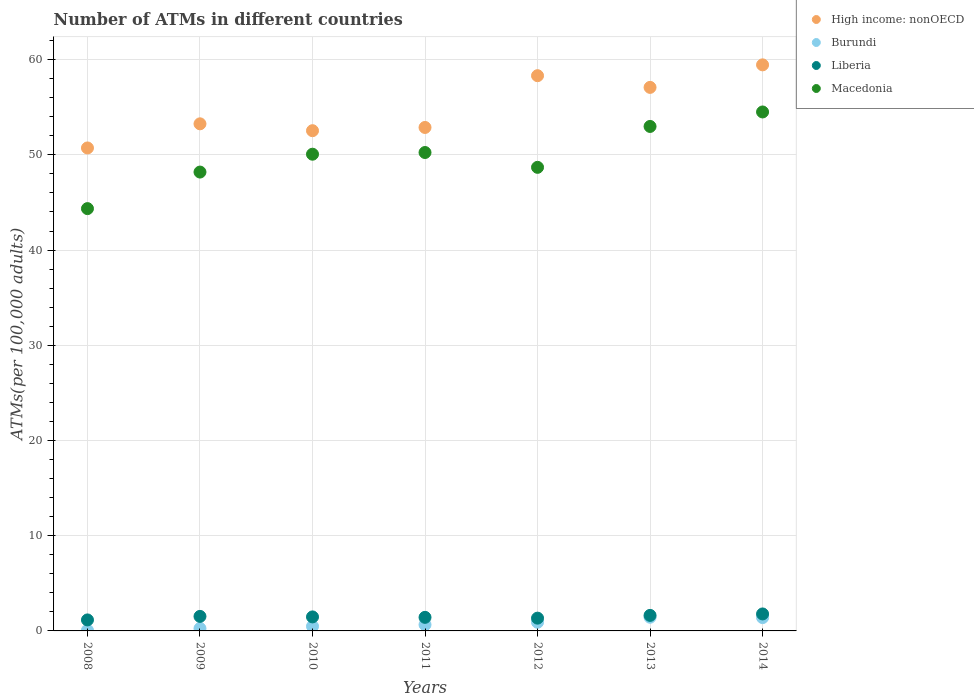How many different coloured dotlines are there?
Ensure brevity in your answer.  4. Is the number of dotlines equal to the number of legend labels?
Make the answer very short. Yes. What is the number of ATMs in Burundi in 2014?
Your response must be concise. 1.4. Across all years, what is the maximum number of ATMs in Liberia?
Make the answer very short. 1.78. Across all years, what is the minimum number of ATMs in Liberia?
Your answer should be compact. 1.16. In which year was the number of ATMs in High income: nonOECD maximum?
Give a very brief answer. 2014. What is the total number of ATMs in Burundi in the graph?
Make the answer very short. 5.21. What is the difference between the number of ATMs in Macedonia in 2008 and that in 2009?
Ensure brevity in your answer.  -3.84. What is the difference between the number of ATMs in Burundi in 2012 and the number of ATMs in High income: nonOECD in 2008?
Give a very brief answer. -49.81. What is the average number of ATMs in High income: nonOECD per year?
Offer a terse response. 54.89. In the year 2010, what is the difference between the number of ATMs in Liberia and number of ATMs in Burundi?
Your answer should be compact. 0.99. In how many years, is the number of ATMs in Macedonia greater than 14?
Your answer should be compact. 7. What is the ratio of the number of ATMs in High income: nonOECD in 2010 to that in 2012?
Give a very brief answer. 0.9. Is the number of ATMs in Liberia in 2008 less than that in 2014?
Offer a terse response. Yes. What is the difference between the highest and the second highest number of ATMs in Macedonia?
Make the answer very short. 1.52. What is the difference between the highest and the lowest number of ATMs in Liberia?
Keep it short and to the point. 0.63. In how many years, is the number of ATMs in Burundi greater than the average number of ATMs in Burundi taken over all years?
Ensure brevity in your answer.  3. Is the sum of the number of ATMs in Liberia in 2012 and 2013 greater than the maximum number of ATMs in High income: nonOECD across all years?
Provide a succinct answer. No. Does the number of ATMs in Liberia monotonically increase over the years?
Ensure brevity in your answer.  No. Is the number of ATMs in Liberia strictly greater than the number of ATMs in Macedonia over the years?
Give a very brief answer. No. Is the number of ATMs in Macedonia strictly less than the number of ATMs in Liberia over the years?
Make the answer very short. No. How many years are there in the graph?
Provide a succinct answer. 7. What is the difference between two consecutive major ticks on the Y-axis?
Your response must be concise. 10. Does the graph contain grids?
Your answer should be very brief. Yes. How many legend labels are there?
Offer a terse response. 4. How are the legend labels stacked?
Your answer should be compact. Vertical. What is the title of the graph?
Keep it short and to the point. Number of ATMs in different countries. What is the label or title of the Y-axis?
Keep it short and to the point. ATMs(per 100,0 adults). What is the ATMs(per 100,000 adults) in High income: nonOECD in 2008?
Your response must be concise. 50.72. What is the ATMs(per 100,000 adults) of Burundi in 2008?
Offer a terse response. 0.06. What is the ATMs(per 100,000 adults) of Liberia in 2008?
Your response must be concise. 1.16. What is the ATMs(per 100,000 adults) in Macedonia in 2008?
Offer a very short reply. 44.35. What is the ATMs(per 100,000 adults) of High income: nonOECD in 2009?
Make the answer very short. 53.26. What is the ATMs(per 100,000 adults) in Burundi in 2009?
Make the answer very short. 0.26. What is the ATMs(per 100,000 adults) in Liberia in 2009?
Provide a short and direct response. 1.53. What is the ATMs(per 100,000 adults) in Macedonia in 2009?
Keep it short and to the point. 48.19. What is the ATMs(per 100,000 adults) in High income: nonOECD in 2010?
Offer a very short reply. 52.53. What is the ATMs(per 100,000 adults) in Burundi in 2010?
Provide a succinct answer. 0.48. What is the ATMs(per 100,000 adults) in Liberia in 2010?
Make the answer very short. 1.47. What is the ATMs(per 100,000 adults) of Macedonia in 2010?
Ensure brevity in your answer.  50.07. What is the ATMs(per 100,000 adults) of High income: nonOECD in 2011?
Your response must be concise. 52.87. What is the ATMs(per 100,000 adults) in Burundi in 2011?
Make the answer very short. 0.66. What is the ATMs(per 100,000 adults) of Liberia in 2011?
Provide a succinct answer. 1.42. What is the ATMs(per 100,000 adults) of Macedonia in 2011?
Ensure brevity in your answer.  50.24. What is the ATMs(per 100,000 adults) in High income: nonOECD in 2012?
Offer a very short reply. 58.31. What is the ATMs(per 100,000 adults) in Burundi in 2012?
Your answer should be very brief. 0.91. What is the ATMs(per 100,000 adults) of Liberia in 2012?
Your response must be concise. 1.34. What is the ATMs(per 100,000 adults) in Macedonia in 2012?
Your answer should be very brief. 48.69. What is the ATMs(per 100,000 adults) in High income: nonOECD in 2013?
Provide a succinct answer. 57.08. What is the ATMs(per 100,000 adults) of Burundi in 2013?
Offer a very short reply. 1.44. What is the ATMs(per 100,000 adults) of Liberia in 2013?
Provide a short and direct response. 1.63. What is the ATMs(per 100,000 adults) in Macedonia in 2013?
Your response must be concise. 52.98. What is the ATMs(per 100,000 adults) of High income: nonOECD in 2014?
Keep it short and to the point. 59.45. What is the ATMs(per 100,000 adults) of Burundi in 2014?
Offer a very short reply. 1.4. What is the ATMs(per 100,000 adults) in Liberia in 2014?
Offer a very short reply. 1.78. What is the ATMs(per 100,000 adults) in Macedonia in 2014?
Give a very brief answer. 54.5. Across all years, what is the maximum ATMs(per 100,000 adults) in High income: nonOECD?
Ensure brevity in your answer.  59.45. Across all years, what is the maximum ATMs(per 100,000 adults) of Burundi?
Offer a terse response. 1.44. Across all years, what is the maximum ATMs(per 100,000 adults) in Liberia?
Provide a short and direct response. 1.78. Across all years, what is the maximum ATMs(per 100,000 adults) of Macedonia?
Offer a very short reply. 54.5. Across all years, what is the minimum ATMs(per 100,000 adults) in High income: nonOECD?
Your answer should be very brief. 50.72. Across all years, what is the minimum ATMs(per 100,000 adults) of Burundi?
Make the answer very short. 0.06. Across all years, what is the minimum ATMs(per 100,000 adults) in Liberia?
Ensure brevity in your answer.  1.16. Across all years, what is the minimum ATMs(per 100,000 adults) in Macedonia?
Your response must be concise. 44.35. What is the total ATMs(per 100,000 adults) of High income: nonOECD in the graph?
Ensure brevity in your answer.  384.23. What is the total ATMs(per 100,000 adults) of Burundi in the graph?
Make the answer very short. 5.21. What is the total ATMs(per 100,000 adults) in Liberia in the graph?
Offer a terse response. 10.33. What is the total ATMs(per 100,000 adults) of Macedonia in the graph?
Offer a very short reply. 349.02. What is the difference between the ATMs(per 100,000 adults) of High income: nonOECD in 2008 and that in 2009?
Make the answer very short. -2.53. What is the difference between the ATMs(per 100,000 adults) in Burundi in 2008 and that in 2009?
Offer a terse response. -0.2. What is the difference between the ATMs(per 100,000 adults) of Liberia in 2008 and that in 2009?
Your answer should be very brief. -0.37. What is the difference between the ATMs(per 100,000 adults) of Macedonia in 2008 and that in 2009?
Provide a short and direct response. -3.84. What is the difference between the ATMs(per 100,000 adults) of High income: nonOECD in 2008 and that in 2010?
Offer a terse response. -1.81. What is the difference between the ATMs(per 100,000 adults) of Burundi in 2008 and that in 2010?
Keep it short and to the point. -0.42. What is the difference between the ATMs(per 100,000 adults) in Liberia in 2008 and that in 2010?
Provide a succinct answer. -0.32. What is the difference between the ATMs(per 100,000 adults) in Macedonia in 2008 and that in 2010?
Your answer should be very brief. -5.71. What is the difference between the ATMs(per 100,000 adults) in High income: nonOECD in 2008 and that in 2011?
Your response must be concise. -2.15. What is the difference between the ATMs(per 100,000 adults) of Burundi in 2008 and that in 2011?
Offer a very short reply. -0.59. What is the difference between the ATMs(per 100,000 adults) of Liberia in 2008 and that in 2011?
Keep it short and to the point. -0.27. What is the difference between the ATMs(per 100,000 adults) in Macedonia in 2008 and that in 2011?
Make the answer very short. -5.89. What is the difference between the ATMs(per 100,000 adults) of High income: nonOECD in 2008 and that in 2012?
Offer a terse response. -7.59. What is the difference between the ATMs(per 100,000 adults) of Burundi in 2008 and that in 2012?
Ensure brevity in your answer.  -0.85. What is the difference between the ATMs(per 100,000 adults) in Liberia in 2008 and that in 2012?
Your answer should be compact. -0.19. What is the difference between the ATMs(per 100,000 adults) of Macedonia in 2008 and that in 2012?
Provide a succinct answer. -4.34. What is the difference between the ATMs(per 100,000 adults) in High income: nonOECD in 2008 and that in 2013?
Provide a short and direct response. -6.36. What is the difference between the ATMs(per 100,000 adults) of Burundi in 2008 and that in 2013?
Your answer should be compact. -1.38. What is the difference between the ATMs(per 100,000 adults) in Liberia in 2008 and that in 2013?
Provide a short and direct response. -0.48. What is the difference between the ATMs(per 100,000 adults) in Macedonia in 2008 and that in 2013?
Offer a very short reply. -8.63. What is the difference between the ATMs(per 100,000 adults) in High income: nonOECD in 2008 and that in 2014?
Provide a succinct answer. -8.73. What is the difference between the ATMs(per 100,000 adults) in Burundi in 2008 and that in 2014?
Your answer should be very brief. -1.34. What is the difference between the ATMs(per 100,000 adults) of Liberia in 2008 and that in 2014?
Your answer should be very brief. -0.63. What is the difference between the ATMs(per 100,000 adults) in Macedonia in 2008 and that in 2014?
Your answer should be very brief. -10.15. What is the difference between the ATMs(per 100,000 adults) of High income: nonOECD in 2009 and that in 2010?
Provide a short and direct response. 0.72. What is the difference between the ATMs(per 100,000 adults) of Burundi in 2009 and that in 2010?
Your answer should be very brief. -0.22. What is the difference between the ATMs(per 100,000 adults) in Liberia in 2009 and that in 2010?
Give a very brief answer. 0.05. What is the difference between the ATMs(per 100,000 adults) in Macedonia in 2009 and that in 2010?
Your answer should be very brief. -1.88. What is the difference between the ATMs(per 100,000 adults) in High income: nonOECD in 2009 and that in 2011?
Offer a terse response. 0.38. What is the difference between the ATMs(per 100,000 adults) of Burundi in 2009 and that in 2011?
Your response must be concise. -0.4. What is the difference between the ATMs(per 100,000 adults) in Liberia in 2009 and that in 2011?
Your response must be concise. 0.1. What is the difference between the ATMs(per 100,000 adults) of Macedonia in 2009 and that in 2011?
Your answer should be very brief. -2.05. What is the difference between the ATMs(per 100,000 adults) of High income: nonOECD in 2009 and that in 2012?
Your response must be concise. -5.05. What is the difference between the ATMs(per 100,000 adults) in Burundi in 2009 and that in 2012?
Give a very brief answer. -0.65. What is the difference between the ATMs(per 100,000 adults) in Liberia in 2009 and that in 2012?
Keep it short and to the point. 0.19. What is the difference between the ATMs(per 100,000 adults) in Macedonia in 2009 and that in 2012?
Provide a succinct answer. -0.5. What is the difference between the ATMs(per 100,000 adults) in High income: nonOECD in 2009 and that in 2013?
Your answer should be very brief. -3.83. What is the difference between the ATMs(per 100,000 adults) of Burundi in 2009 and that in 2013?
Offer a very short reply. -1.18. What is the difference between the ATMs(per 100,000 adults) of Liberia in 2009 and that in 2013?
Your response must be concise. -0.1. What is the difference between the ATMs(per 100,000 adults) of Macedonia in 2009 and that in 2013?
Give a very brief answer. -4.79. What is the difference between the ATMs(per 100,000 adults) in High income: nonOECD in 2009 and that in 2014?
Offer a terse response. -6.19. What is the difference between the ATMs(per 100,000 adults) in Burundi in 2009 and that in 2014?
Provide a short and direct response. -1.14. What is the difference between the ATMs(per 100,000 adults) in Liberia in 2009 and that in 2014?
Give a very brief answer. -0.26. What is the difference between the ATMs(per 100,000 adults) in Macedonia in 2009 and that in 2014?
Make the answer very short. -6.31. What is the difference between the ATMs(per 100,000 adults) of High income: nonOECD in 2010 and that in 2011?
Make the answer very short. -0.34. What is the difference between the ATMs(per 100,000 adults) in Burundi in 2010 and that in 2011?
Make the answer very short. -0.17. What is the difference between the ATMs(per 100,000 adults) in Liberia in 2010 and that in 2011?
Your response must be concise. 0.05. What is the difference between the ATMs(per 100,000 adults) of Macedonia in 2010 and that in 2011?
Your answer should be very brief. -0.18. What is the difference between the ATMs(per 100,000 adults) in High income: nonOECD in 2010 and that in 2012?
Keep it short and to the point. -5.78. What is the difference between the ATMs(per 100,000 adults) of Burundi in 2010 and that in 2012?
Keep it short and to the point. -0.43. What is the difference between the ATMs(per 100,000 adults) of Liberia in 2010 and that in 2012?
Your answer should be compact. 0.13. What is the difference between the ATMs(per 100,000 adults) in Macedonia in 2010 and that in 2012?
Provide a succinct answer. 1.38. What is the difference between the ATMs(per 100,000 adults) in High income: nonOECD in 2010 and that in 2013?
Ensure brevity in your answer.  -4.55. What is the difference between the ATMs(per 100,000 adults) in Burundi in 2010 and that in 2013?
Your response must be concise. -0.95. What is the difference between the ATMs(per 100,000 adults) in Liberia in 2010 and that in 2013?
Make the answer very short. -0.16. What is the difference between the ATMs(per 100,000 adults) of Macedonia in 2010 and that in 2013?
Your answer should be very brief. -2.92. What is the difference between the ATMs(per 100,000 adults) of High income: nonOECD in 2010 and that in 2014?
Keep it short and to the point. -6.92. What is the difference between the ATMs(per 100,000 adults) of Burundi in 2010 and that in 2014?
Keep it short and to the point. -0.92. What is the difference between the ATMs(per 100,000 adults) in Liberia in 2010 and that in 2014?
Provide a short and direct response. -0.31. What is the difference between the ATMs(per 100,000 adults) in Macedonia in 2010 and that in 2014?
Give a very brief answer. -4.44. What is the difference between the ATMs(per 100,000 adults) in High income: nonOECD in 2011 and that in 2012?
Give a very brief answer. -5.44. What is the difference between the ATMs(per 100,000 adults) of Burundi in 2011 and that in 2012?
Offer a very short reply. -0.25. What is the difference between the ATMs(per 100,000 adults) in Liberia in 2011 and that in 2012?
Offer a very short reply. 0.08. What is the difference between the ATMs(per 100,000 adults) in Macedonia in 2011 and that in 2012?
Provide a succinct answer. 1.56. What is the difference between the ATMs(per 100,000 adults) of High income: nonOECD in 2011 and that in 2013?
Make the answer very short. -4.21. What is the difference between the ATMs(per 100,000 adults) of Burundi in 2011 and that in 2013?
Provide a succinct answer. -0.78. What is the difference between the ATMs(per 100,000 adults) in Liberia in 2011 and that in 2013?
Provide a succinct answer. -0.21. What is the difference between the ATMs(per 100,000 adults) of Macedonia in 2011 and that in 2013?
Your response must be concise. -2.74. What is the difference between the ATMs(per 100,000 adults) of High income: nonOECD in 2011 and that in 2014?
Your answer should be compact. -6.58. What is the difference between the ATMs(per 100,000 adults) in Burundi in 2011 and that in 2014?
Offer a very short reply. -0.74. What is the difference between the ATMs(per 100,000 adults) of Liberia in 2011 and that in 2014?
Your response must be concise. -0.36. What is the difference between the ATMs(per 100,000 adults) in Macedonia in 2011 and that in 2014?
Ensure brevity in your answer.  -4.26. What is the difference between the ATMs(per 100,000 adults) in High income: nonOECD in 2012 and that in 2013?
Your answer should be compact. 1.23. What is the difference between the ATMs(per 100,000 adults) in Burundi in 2012 and that in 2013?
Offer a terse response. -0.53. What is the difference between the ATMs(per 100,000 adults) in Liberia in 2012 and that in 2013?
Provide a short and direct response. -0.29. What is the difference between the ATMs(per 100,000 adults) of Macedonia in 2012 and that in 2013?
Provide a short and direct response. -4.29. What is the difference between the ATMs(per 100,000 adults) in High income: nonOECD in 2012 and that in 2014?
Provide a short and direct response. -1.14. What is the difference between the ATMs(per 100,000 adults) of Burundi in 2012 and that in 2014?
Your answer should be compact. -0.49. What is the difference between the ATMs(per 100,000 adults) in Liberia in 2012 and that in 2014?
Keep it short and to the point. -0.44. What is the difference between the ATMs(per 100,000 adults) of Macedonia in 2012 and that in 2014?
Give a very brief answer. -5.81. What is the difference between the ATMs(per 100,000 adults) in High income: nonOECD in 2013 and that in 2014?
Ensure brevity in your answer.  -2.37. What is the difference between the ATMs(per 100,000 adults) of Burundi in 2013 and that in 2014?
Provide a short and direct response. 0.04. What is the difference between the ATMs(per 100,000 adults) of Liberia in 2013 and that in 2014?
Ensure brevity in your answer.  -0.15. What is the difference between the ATMs(per 100,000 adults) of Macedonia in 2013 and that in 2014?
Make the answer very short. -1.52. What is the difference between the ATMs(per 100,000 adults) in High income: nonOECD in 2008 and the ATMs(per 100,000 adults) in Burundi in 2009?
Your response must be concise. 50.46. What is the difference between the ATMs(per 100,000 adults) of High income: nonOECD in 2008 and the ATMs(per 100,000 adults) of Liberia in 2009?
Offer a very short reply. 49.2. What is the difference between the ATMs(per 100,000 adults) in High income: nonOECD in 2008 and the ATMs(per 100,000 adults) in Macedonia in 2009?
Give a very brief answer. 2.53. What is the difference between the ATMs(per 100,000 adults) in Burundi in 2008 and the ATMs(per 100,000 adults) in Liberia in 2009?
Offer a very short reply. -1.46. What is the difference between the ATMs(per 100,000 adults) in Burundi in 2008 and the ATMs(per 100,000 adults) in Macedonia in 2009?
Offer a very short reply. -48.13. What is the difference between the ATMs(per 100,000 adults) of Liberia in 2008 and the ATMs(per 100,000 adults) of Macedonia in 2009?
Offer a terse response. -47.03. What is the difference between the ATMs(per 100,000 adults) of High income: nonOECD in 2008 and the ATMs(per 100,000 adults) of Burundi in 2010?
Your answer should be compact. 50.24. What is the difference between the ATMs(per 100,000 adults) of High income: nonOECD in 2008 and the ATMs(per 100,000 adults) of Liberia in 2010?
Keep it short and to the point. 49.25. What is the difference between the ATMs(per 100,000 adults) in High income: nonOECD in 2008 and the ATMs(per 100,000 adults) in Macedonia in 2010?
Your response must be concise. 0.66. What is the difference between the ATMs(per 100,000 adults) in Burundi in 2008 and the ATMs(per 100,000 adults) in Liberia in 2010?
Offer a very short reply. -1.41. What is the difference between the ATMs(per 100,000 adults) in Burundi in 2008 and the ATMs(per 100,000 adults) in Macedonia in 2010?
Your answer should be very brief. -50. What is the difference between the ATMs(per 100,000 adults) of Liberia in 2008 and the ATMs(per 100,000 adults) of Macedonia in 2010?
Offer a terse response. -48.91. What is the difference between the ATMs(per 100,000 adults) of High income: nonOECD in 2008 and the ATMs(per 100,000 adults) of Burundi in 2011?
Ensure brevity in your answer.  50.07. What is the difference between the ATMs(per 100,000 adults) of High income: nonOECD in 2008 and the ATMs(per 100,000 adults) of Liberia in 2011?
Keep it short and to the point. 49.3. What is the difference between the ATMs(per 100,000 adults) in High income: nonOECD in 2008 and the ATMs(per 100,000 adults) in Macedonia in 2011?
Your answer should be compact. 0.48. What is the difference between the ATMs(per 100,000 adults) of Burundi in 2008 and the ATMs(per 100,000 adults) of Liberia in 2011?
Your answer should be compact. -1.36. What is the difference between the ATMs(per 100,000 adults) in Burundi in 2008 and the ATMs(per 100,000 adults) in Macedonia in 2011?
Give a very brief answer. -50.18. What is the difference between the ATMs(per 100,000 adults) of Liberia in 2008 and the ATMs(per 100,000 adults) of Macedonia in 2011?
Your response must be concise. -49.09. What is the difference between the ATMs(per 100,000 adults) in High income: nonOECD in 2008 and the ATMs(per 100,000 adults) in Burundi in 2012?
Give a very brief answer. 49.81. What is the difference between the ATMs(per 100,000 adults) in High income: nonOECD in 2008 and the ATMs(per 100,000 adults) in Liberia in 2012?
Ensure brevity in your answer.  49.38. What is the difference between the ATMs(per 100,000 adults) of High income: nonOECD in 2008 and the ATMs(per 100,000 adults) of Macedonia in 2012?
Make the answer very short. 2.04. What is the difference between the ATMs(per 100,000 adults) in Burundi in 2008 and the ATMs(per 100,000 adults) in Liberia in 2012?
Provide a short and direct response. -1.28. What is the difference between the ATMs(per 100,000 adults) of Burundi in 2008 and the ATMs(per 100,000 adults) of Macedonia in 2012?
Your answer should be very brief. -48.62. What is the difference between the ATMs(per 100,000 adults) of Liberia in 2008 and the ATMs(per 100,000 adults) of Macedonia in 2012?
Your answer should be very brief. -47.53. What is the difference between the ATMs(per 100,000 adults) in High income: nonOECD in 2008 and the ATMs(per 100,000 adults) in Burundi in 2013?
Make the answer very short. 49.28. What is the difference between the ATMs(per 100,000 adults) in High income: nonOECD in 2008 and the ATMs(per 100,000 adults) in Liberia in 2013?
Give a very brief answer. 49.09. What is the difference between the ATMs(per 100,000 adults) in High income: nonOECD in 2008 and the ATMs(per 100,000 adults) in Macedonia in 2013?
Provide a succinct answer. -2.26. What is the difference between the ATMs(per 100,000 adults) in Burundi in 2008 and the ATMs(per 100,000 adults) in Liberia in 2013?
Provide a succinct answer. -1.57. What is the difference between the ATMs(per 100,000 adults) of Burundi in 2008 and the ATMs(per 100,000 adults) of Macedonia in 2013?
Keep it short and to the point. -52.92. What is the difference between the ATMs(per 100,000 adults) of Liberia in 2008 and the ATMs(per 100,000 adults) of Macedonia in 2013?
Your answer should be compact. -51.83. What is the difference between the ATMs(per 100,000 adults) in High income: nonOECD in 2008 and the ATMs(per 100,000 adults) in Burundi in 2014?
Offer a terse response. 49.32. What is the difference between the ATMs(per 100,000 adults) of High income: nonOECD in 2008 and the ATMs(per 100,000 adults) of Liberia in 2014?
Offer a very short reply. 48.94. What is the difference between the ATMs(per 100,000 adults) in High income: nonOECD in 2008 and the ATMs(per 100,000 adults) in Macedonia in 2014?
Keep it short and to the point. -3.78. What is the difference between the ATMs(per 100,000 adults) in Burundi in 2008 and the ATMs(per 100,000 adults) in Liberia in 2014?
Provide a succinct answer. -1.72. What is the difference between the ATMs(per 100,000 adults) of Burundi in 2008 and the ATMs(per 100,000 adults) of Macedonia in 2014?
Keep it short and to the point. -54.44. What is the difference between the ATMs(per 100,000 adults) in Liberia in 2008 and the ATMs(per 100,000 adults) in Macedonia in 2014?
Provide a short and direct response. -53.35. What is the difference between the ATMs(per 100,000 adults) in High income: nonOECD in 2009 and the ATMs(per 100,000 adults) in Burundi in 2010?
Offer a very short reply. 52.77. What is the difference between the ATMs(per 100,000 adults) of High income: nonOECD in 2009 and the ATMs(per 100,000 adults) of Liberia in 2010?
Offer a terse response. 51.78. What is the difference between the ATMs(per 100,000 adults) in High income: nonOECD in 2009 and the ATMs(per 100,000 adults) in Macedonia in 2010?
Make the answer very short. 3.19. What is the difference between the ATMs(per 100,000 adults) of Burundi in 2009 and the ATMs(per 100,000 adults) of Liberia in 2010?
Your answer should be very brief. -1.21. What is the difference between the ATMs(per 100,000 adults) in Burundi in 2009 and the ATMs(per 100,000 adults) in Macedonia in 2010?
Provide a succinct answer. -49.81. What is the difference between the ATMs(per 100,000 adults) of Liberia in 2009 and the ATMs(per 100,000 adults) of Macedonia in 2010?
Make the answer very short. -48.54. What is the difference between the ATMs(per 100,000 adults) of High income: nonOECD in 2009 and the ATMs(per 100,000 adults) of Burundi in 2011?
Your answer should be compact. 52.6. What is the difference between the ATMs(per 100,000 adults) in High income: nonOECD in 2009 and the ATMs(per 100,000 adults) in Liberia in 2011?
Give a very brief answer. 51.83. What is the difference between the ATMs(per 100,000 adults) in High income: nonOECD in 2009 and the ATMs(per 100,000 adults) in Macedonia in 2011?
Provide a succinct answer. 3.01. What is the difference between the ATMs(per 100,000 adults) of Burundi in 2009 and the ATMs(per 100,000 adults) of Liberia in 2011?
Offer a terse response. -1.16. What is the difference between the ATMs(per 100,000 adults) in Burundi in 2009 and the ATMs(per 100,000 adults) in Macedonia in 2011?
Your answer should be compact. -49.98. What is the difference between the ATMs(per 100,000 adults) of Liberia in 2009 and the ATMs(per 100,000 adults) of Macedonia in 2011?
Give a very brief answer. -48.72. What is the difference between the ATMs(per 100,000 adults) of High income: nonOECD in 2009 and the ATMs(per 100,000 adults) of Burundi in 2012?
Your response must be concise. 52.35. What is the difference between the ATMs(per 100,000 adults) in High income: nonOECD in 2009 and the ATMs(per 100,000 adults) in Liberia in 2012?
Offer a terse response. 51.92. What is the difference between the ATMs(per 100,000 adults) of High income: nonOECD in 2009 and the ATMs(per 100,000 adults) of Macedonia in 2012?
Give a very brief answer. 4.57. What is the difference between the ATMs(per 100,000 adults) of Burundi in 2009 and the ATMs(per 100,000 adults) of Liberia in 2012?
Offer a terse response. -1.08. What is the difference between the ATMs(per 100,000 adults) of Burundi in 2009 and the ATMs(per 100,000 adults) of Macedonia in 2012?
Offer a terse response. -48.43. What is the difference between the ATMs(per 100,000 adults) in Liberia in 2009 and the ATMs(per 100,000 adults) in Macedonia in 2012?
Keep it short and to the point. -47.16. What is the difference between the ATMs(per 100,000 adults) of High income: nonOECD in 2009 and the ATMs(per 100,000 adults) of Burundi in 2013?
Offer a very short reply. 51.82. What is the difference between the ATMs(per 100,000 adults) in High income: nonOECD in 2009 and the ATMs(per 100,000 adults) in Liberia in 2013?
Ensure brevity in your answer.  51.63. What is the difference between the ATMs(per 100,000 adults) in High income: nonOECD in 2009 and the ATMs(per 100,000 adults) in Macedonia in 2013?
Provide a short and direct response. 0.28. What is the difference between the ATMs(per 100,000 adults) of Burundi in 2009 and the ATMs(per 100,000 adults) of Liberia in 2013?
Ensure brevity in your answer.  -1.37. What is the difference between the ATMs(per 100,000 adults) of Burundi in 2009 and the ATMs(per 100,000 adults) of Macedonia in 2013?
Your answer should be very brief. -52.72. What is the difference between the ATMs(per 100,000 adults) in Liberia in 2009 and the ATMs(per 100,000 adults) in Macedonia in 2013?
Provide a succinct answer. -51.46. What is the difference between the ATMs(per 100,000 adults) in High income: nonOECD in 2009 and the ATMs(per 100,000 adults) in Burundi in 2014?
Make the answer very short. 51.86. What is the difference between the ATMs(per 100,000 adults) of High income: nonOECD in 2009 and the ATMs(per 100,000 adults) of Liberia in 2014?
Provide a succinct answer. 51.47. What is the difference between the ATMs(per 100,000 adults) of High income: nonOECD in 2009 and the ATMs(per 100,000 adults) of Macedonia in 2014?
Ensure brevity in your answer.  -1.24. What is the difference between the ATMs(per 100,000 adults) in Burundi in 2009 and the ATMs(per 100,000 adults) in Liberia in 2014?
Ensure brevity in your answer.  -1.52. What is the difference between the ATMs(per 100,000 adults) in Burundi in 2009 and the ATMs(per 100,000 adults) in Macedonia in 2014?
Offer a very short reply. -54.24. What is the difference between the ATMs(per 100,000 adults) in Liberia in 2009 and the ATMs(per 100,000 adults) in Macedonia in 2014?
Your response must be concise. -52.98. What is the difference between the ATMs(per 100,000 adults) in High income: nonOECD in 2010 and the ATMs(per 100,000 adults) in Burundi in 2011?
Provide a succinct answer. 51.88. What is the difference between the ATMs(per 100,000 adults) in High income: nonOECD in 2010 and the ATMs(per 100,000 adults) in Liberia in 2011?
Ensure brevity in your answer.  51.11. What is the difference between the ATMs(per 100,000 adults) in High income: nonOECD in 2010 and the ATMs(per 100,000 adults) in Macedonia in 2011?
Ensure brevity in your answer.  2.29. What is the difference between the ATMs(per 100,000 adults) of Burundi in 2010 and the ATMs(per 100,000 adults) of Liberia in 2011?
Ensure brevity in your answer.  -0.94. What is the difference between the ATMs(per 100,000 adults) of Burundi in 2010 and the ATMs(per 100,000 adults) of Macedonia in 2011?
Provide a short and direct response. -49.76. What is the difference between the ATMs(per 100,000 adults) of Liberia in 2010 and the ATMs(per 100,000 adults) of Macedonia in 2011?
Keep it short and to the point. -48.77. What is the difference between the ATMs(per 100,000 adults) of High income: nonOECD in 2010 and the ATMs(per 100,000 adults) of Burundi in 2012?
Offer a very short reply. 51.62. What is the difference between the ATMs(per 100,000 adults) in High income: nonOECD in 2010 and the ATMs(per 100,000 adults) in Liberia in 2012?
Offer a very short reply. 51.19. What is the difference between the ATMs(per 100,000 adults) in High income: nonOECD in 2010 and the ATMs(per 100,000 adults) in Macedonia in 2012?
Ensure brevity in your answer.  3.85. What is the difference between the ATMs(per 100,000 adults) in Burundi in 2010 and the ATMs(per 100,000 adults) in Liberia in 2012?
Provide a succinct answer. -0.86. What is the difference between the ATMs(per 100,000 adults) of Burundi in 2010 and the ATMs(per 100,000 adults) of Macedonia in 2012?
Give a very brief answer. -48.2. What is the difference between the ATMs(per 100,000 adults) in Liberia in 2010 and the ATMs(per 100,000 adults) in Macedonia in 2012?
Ensure brevity in your answer.  -47.22. What is the difference between the ATMs(per 100,000 adults) in High income: nonOECD in 2010 and the ATMs(per 100,000 adults) in Burundi in 2013?
Your response must be concise. 51.1. What is the difference between the ATMs(per 100,000 adults) of High income: nonOECD in 2010 and the ATMs(per 100,000 adults) of Liberia in 2013?
Give a very brief answer. 50.9. What is the difference between the ATMs(per 100,000 adults) of High income: nonOECD in 2010 and the ATMs(per 100,000 adults) of Macedonia in 2013?
Give a very brief answer. -0.45. What is the difference between the ATMs(per 100,000 adults) in Burundi in 2010 and the ATMs(per 100,000 adults) in Liberia in 2013?
Provide a short and direct response. -1.15. What is the difference between the ATMs(per 100,000 adults) in Burundi in 2010 and the ATMs(per 100,000 adults) in Macedonia in 2013?
Give a very brief answer. -52.5. What is the difference between the ATMs(per 100,000 adults) in Liberia in 2010 and the ATMs(per 100,000 adults) in Macedonia in 2013?
Offer a very short reply. -51.51. What is the difference between the ATMs(per 100,000 adults) of High income: nonOECD in 2010 and the ATMs(per 100,000 adults) of Burundi in 2014?
Provide a succinct answer. 51.14. What is the difference between the ATMs(per 100,000 adults) of High income: nonOECD in 2010 and the ATMs(per 100,000 adults) of Liberia in 2014?
Offer a very short reply. 50.75. What is the difference between the ATMs(per 100,000 adults) in High income: nonOECD in 2010 and the ATMs(per 100,000 adults) in Macedonia in 2014?
Make the answer very short. -1.97. What is the difference between the ATMs(per 100,000 adults) in Burundi in 2010 and the ATMs(per 100,000 adults) in Liberia in 2014?
Your answer should be compact. -1.3. What is the difference between the ATMs(per 100,000 adults) in Burundi in 2010 and the ATMs(per 100,000 adults) in Macedonia in 2014?
Your answer should be very brief. -54.02. What is the difference between the ATMs(per 100,000 adults) of Liberia in 2010 and the ATMs(per 100,000 adults) of Macedonia in 2014?
Offer a very short reply. -53.03. What is the difference between the ATMs(per 100,000 adults) in High income: nonOECD in 2011 and the ATMs(per 100,000 adults) in Burundi in 2012?
Offer a terse response. 51.97. What is the difference between the ATMs(per 100,000 adults) of High income: nonOECD in 2011 and the ATMs(per 100,000 adults) of Liberia in 2012?
Offer a terse response. 51.53. What is the difference between the ATMs(per 100,000 adults) of High income: nonOECD in 2011 and the ATMs(per 100,000 adults) of Macedonia in 2012?
Offer a terse response. 4.19. What is the difference between the ATMs(per 100,000 adults) of Burundi in 2011 and the ATMs(per 100,000 adults) of Liberia in 2012?
Give a very brief answer. -0.69. What is the difference between the ATMs(per 100,000 adults) in Burundi in 2011 and the ATMs(per 100,000 adults) in Macedonia in 2012?
Your answer should be compact. -48.03. What is the difference between the ATMs(per 100,000 adults) of Liberia in 2011 and the ATMs(per 100,000 adults) of Macedonia in 2012?
Provide a short and direct response. -47.26. What is the difference between the ATMs(per 100,000 adults) in High income: nonOECD in 2011 and the ATMs(per 100,000 adults) in Burundi in 2013?
Provide a succinct answer. 51.44. What is the difference between the ATMs(per 100,000 adults) in High income: nonOECD in 2011 and the ATMs(per 100,000 adults) in Liberia in 2013?
Your response must be concise. 51.24. What is the difference between the ATMs(per 100,000 adults) in High income: nonOECD in 2011 and the ATMs(per 100,000 adults) in Macedonia in 2013?
Ensure brevity in your answer.  -0.11. What is the difference between the ATMs(per 100,000 adults) in Burundi in 2011 and the ATMs(per 100,000 adults) in Liberia in 2013?
Provide a short and direct response. -0.98. What is the difference between the ATMs(per 100,000 adults) in Burundi in 2011 and the ATMs(per 100,000 adults) in Macedonia in 2013?
Provide a short and direct response. -52.33. What is the difference between the ATMs(per 100,000 adults) of Liberia in 2011 and the ATMs(per 100,000 adults) of Macedonia in 2013?
Give a very brief answer. -51.56. What is the difference between the ATMs(per 100,000 adults) of High income: nonOECD in 2011 and the ATMs(per 100,000 adults) of Burundi in 2014?
Provide a succinct answer. 51.48. What is the difference between the ATMs(per 100,000 adults) in High income: nonOECD in 2011 and the ATMs(per 100,000 adults) in Liberia in 2014?
Your response must be concise. 51.09. What is the difference between the ATMs(per 100,000 adults) in High income: nonOECD in 2011 and the ATMs(per 100,000 adults) in Macedonia in 2014?
Ensure brevity in your answer.  -1.63. What is the difference between the ATMs(per 100,000 adults) of Burundi in 2011 and the ATMs(per 100,000 adults) of Liberia in 2014?
Provide a succinct answer. -1.13. What is the difference between the ATMs(per 100,000 adults) of Burundi in 2011 and the ATMs(per 100,000 adults) of Macedonia in 2014?
Ensure brevity in your answer.  -53.85. What is the difference between the ATMs(per 100,000 adults) of Liberia in 2011 and the ATMs(per 100,000 adults) of Macedonia in 2014?
Make the answer very short. -53.08. What is the difference between the ATMs(per 100,000 adults) in High income: nonOECD in 2012 and the ATMs(per 100,000 adults) in Burundi in 2013?
Your answer should be compact. 56.87. What is the difference between the ATMs(per 100,000 adults) of High income: nonOECD in 2012 and the ATMs(per 100,000 adults) of Liberia in 2013?
Provide a succinct answer. 56.68. What is the difference between the ATMs(per 100,000 adults) in High income: nonOECD in 2012 and the ATMs(per 100,000 adults) in Macedonia in 2013?
Provide a short and direct response. 5.33. What is the difference between the ATMs(per 100,000 adults) in Burundi in 2012 and the ATMs(per 100,000 adults) in Liberia in 2013?
Ensure brevity in your answer.  -0.72. What is the difference between the ATMs(per 100,000 adults) in Burundi in 2012 and the ATMs(per 100,000 adults) in Macedonia in 2013?
Provide a succinct answer. -52.07. What is the difference between the ATMs(per 100,000 adults) in Liberia in 2012 and the ATMs(per 100,000 adults) in Macedonia in 2013?
Your answer should be compact. -51.64. What is the difference between the ATMs(per 100,000 adults) of High income: nonOECD in 2012 and the ATMs(per 100,000 adults) of Burundi in 2014?
Your answer should be compact. 56.91. What is the difference between the ATMs(per 100,000 adults) of High income: nonOECD in 2012 and the ATMs(per 100,000 adults) of Liberia in 2014?
Provide a succinct answer. 56.53. What is the difference between the ATMs(per 100,000 adults) of High income: nonOECD in 2012 and the ATMs(per 100,000 adults) of Macedonia in 2014?
Your answer should be compact. 3.81. What is the difference between the ATMs(per 100,000 adults) in Burundi in 2012 and the ATMs(per 100,000 adults) in Liberia in 2014?
Keep it short and to the point. -0.87. What is the difference between the ATMs(per 100,000 adults) in Burundi in 2012 and the ATMs(per 100,000 adults) in Macedonia in 2014?
Give a very brief answer. -53.59. What is the difference between the ATMs(per 100,000 adults) in Liberia in 2012 and the ATMs(per 100,000 adults) in Macedonia in 2014?
Keep it short and to the point. -53.16. What is the difference between the ATMs(per 100,000 adults) in High income: nonOECD in 2013 and the ATMs(per 100,000 adults) in Burundi in 2014?
Your response must be concise. 55.68. What is the difference between the ATMs(per 100,000 adults) of High income: nonOECD in 2013 and the ATMs(per 100,000 adults) of Liberia in 2014?
Your answer should be compact. 55.3. What is the difference between the ATMs(per 100,000 adults) in High income: nonOECD in 2013 and the ATMs(per 100,000 adults) in Macedonia in 2014?
Keep it short and to the point. 2.58. What is the difference between the ATMs(per 100,000 adults) of Burundi in 2013 and the ATMs(per 100,000 adults) of Liberia in 2014?
Make the answer very short. -0.35. What is the difference between the ATMs(per 100,000 adults) in Burundi in 2013 and the ATMs(per 100,000 adults) in Macedonia in 2014?
Give a very brief answer. -53.06. What is the difference between the ATMs(per 100,000 adults) of Liberia in 2013 and the ATMs(per 100,000 adults) of Macedonia in 2014?
Offer a very short reply. -52.87. What is the average ATMs(per 100,000 adults) in High income: nonOECD per year?
Provide a succinct answer. 54.89. What is the average ATMs(per 100,000 adults) in Burundi per year?
Provide a succinct answer. 0.74. What is the average ATMs(per 100,000 adults) in Liberia per year?
Offer a terse response. 1.48. What is the average ATMs(per 100,000 adults) in Macedonia per year?
Ensure brevity in your answer.  49.86. In the year 2008, what is the difference between the ATMs(per 100,000 adults) of High income: nonOECD and ATMs(per 100,000 adults) of Burundi?
Offer a terse response. 50.66. In the year 2008, what is the difference between the ATMs(per 100,000 adults) of High income: nonOECD and ATMs(per 100,000 adults) of Liberia?
Keep it short and to the point. 49.57. In the year 2008, what is the difference between the ATMs(per 100,000 adults) in High income: nonOECD and ATMs(per 100,000 adults) in Macedonia?
Provide a short and direct response. 6.37. In the year 2008, what is the difference between the ATMs(per 100,000 adults) of Burundi and ATMs(per 100,000 adults) of Liberia?
Provide a succinct answer. -1.09. In the year 2008, what is the difference between the ATMs(per 100,000 adults) in Burundi and ATMs(per 100,000 adults) in Macedonia?
Keep it short and to the point. -44.29. In the year 2008, what is the difference between the ATMs(per 100,000 adults) in Liberia and ATMs(per 100,000 adults) in Macedonia?
Your answer should be very brief. -43.2. In the year 2009, what is the difference between the ATMs(per 100,000 adults) in High income: nonOECD and ATMs(per 100,000 adults) in Burundi?
Offer a terse response. 53. In the year 2009, what is the difference between the ATMs(per 100,000 adults) of High income: nonOECD and ATMs(per 100,000 adults) of Liberia?
Give a very brief answer. 51.73. In the year 2009, what is the difference between the ATMs(per 100,000 adults) of High income: nonOECD and ATMs(per 100,000 adults) of Macedonia?
Provide a succinct answer. 5.07. In the year 2009, what is the difference between the ATMs(per 100,000 adults) in Burundi and ATMs(per 100,000 adults) in Liberia?
Provide a short and direct response. -1.27. In the year 2009, what is the difference between the ATMs(per 100,000 adults) in Burundi and ATMs(per 100,000 adults) in Macedonia?
Keep it short and to the point. -47.93. In the year 2009, what is the difference between the ATMs(per 100,000 adults) of Liberia and ATMs(per 100,000 adults) of Macedonia?
Offer a very short reply. -46.66. In the year 2010, what is the difference between the ATMs(per 100,000 adults) of High income: nonOECD and ATMs(per 100,000 adults) of Burundi?
Ensure brevity in your answer.  52.05. In the year 2010, what is the difference between the ATMs(per 100,000 adults) in High income: nonOECD and ATMs(per 100,000 adults) in Liberia?
Your response must be concise. 51.06. In the year 2010, what is the difference between the ATMs(per 100,000 adults) in High income: nonOECD and ATMs(per 100,000 adults) in Macedonia?
Your answer should be compact. 2.47. In the year 2010, what is the difference between the ATMs(per 100,000 adults) of Burundi and ATMs(per 100,000 adults) of Liberia?
Ensure brevity in your answer.  -0.99. In the year 2010, what is the difference between the ATMs(per 100,000 adults) of Burundi and ATMs(per 100,000 adults) of Macedonia?
Provide a succinct answer. -49.58. In the year 2010, what is the difference between the ATMs(per 100,000 adults) in Liberia and ATMs(per 100,000 adults) in Macedonia?
Provide a short and direct response. -48.59. In the year 2011, what is the difference between the ATMs(per 100,000 adults) in High income: nonOECD and ATMs(per 100,000 adults) in Burundi?
Your answer should be very brief. 52.22. In the year 2011, what is the difference between the ATMs(per 100,000 adults) in High income: nonOECD and ATMs(per 100,000 adults) in Liberia?
Provide a short and direct response. 51.45. In the year 2011, what is the difference between the ATMs(per 100,000 adults) of High income: nonOECD and ATMs(per 100,000 adults) of Macedonia?
Your response must be concise. 2.63. In the year 2011, what is the difference between the ATMs(per 100,000 adults) in Burundi and ATMs(per 100,000 adults) in Liberia?
Keep it short and to the point. -0.77. In the year 2011, what is the difference between the ATMs(per 100,000 adults) in Burundi and ATMs(per 100,000 adults) in Macedonia?
Keep it short and to the point. -49.59. In the year 2011, what is the difference between the ATMs(per 100,000 adults) of Liberia and ATMs(per 100,000 adults) of Macedonia?
Give a very brief answer. -48.82. In the year 2012, what is the difference between the ATMs(per 100,000 adults) of High income: nonOECD and ATMs(per 100,000 adults) of Burundi?
Offer a terse response. 57.4. In the year 2012, what is the difference between the ATMs(per 100,000 adults) in High income: nonOECD and ATMs(per 100,000 adults) in Liberia?
Give a very brief answer. 56.97. In the year 2012, what is the difference between the ATMs(per 100,000 adults) in High income: nonOECD and ATMs(per 100,000 adults) in Macedonia?
Offer a very short reply. 9.62. In the year 2012, what is the difference between the ATMs(per 100,000 adults) in Burundi and ATMs(per 100,000 adults) in Liberia?
Give a very brief answer. -0.43. In the year 2012, what is the difference between the ATMs(per 100,000 adults) in Burundi and ATMs(per 100,000 adults) in Macedonia?
Your answer should be very brief. -47.78. In the year 2012, what is the difference between the ATMs(per 100,000 adults) of Liberia and ATMs(per 100,000 adults) of Macedonia?
Make the answer very short. -47.35. In the year 2013, what is the difference between the ATMs(per 100,000 adults) of High income: nonOECD and ATMs(per 100,000 adults) of Burundi?
Ensure brevity in your answer.  55.65. In the year 2013, what is the difference between the ATMs(per 100,000 adults) in High income: nonOECD and ATMs(per 100,000 adults) in Liberia?
Offer a very short reply. 55.45. In the year 2013, what is the difference between the ATMs(per 100,000 adults) in High income: nonOECD and ATMs(per 100,000 adults) in Macedonia?
Your answer should be very brief. 4.1. In the year 2013, what is the difference between the ATMs(per 100,000 adults) in Burundi and ATMs(per 100,000 adults) in Liberia?
Your answer should be compact. -0.19. In the year 2013, what is the difference between the ATMs(per 100,000 adults) in Burundi and ATMs(per 100,000 adults) in Macedonia?
Your answer should be very brief. -51.54. In the year 2013, what is the difference between the ATMs(per 100,000 adults) in Liberia and ATMs(per 100,000 adults) in Macedonia?
Provide a succinct answer. -51.35. In the year 2014, what is the difference between the ATMs(per 100,000 adults) in High income: nonOECD and ATMs(per 100,000 adults) in Burundi?
Your response must be concise. 58.05. In the year 2014, what is the difference between the ATMs(per 100,000 adults) of High income: nonOECD and ATMs(per 100,000 adults) of Liberia?
Your answer should be compact. 57.67. In the year 2014, what is the difference between the ATMs(per 100,000 adults) in High income: nonOECD and ATMs(per 100,000 adults) in Macedonia?
Your answer should be very brief. 4.95. In the year 2014, what is the difference between the ATMs(per 100,000 adults) of Burundi and ATMs(per 100,000 adults) of Liberia?
Your response must be concise. -0.38. In the year 2014, what is the difference between the ATMs(per 100,000 adults) in Burundi and ATMs(per 100,000 adults) in Macedonia?
Offer a very short reply. -53.1. In the year 2014, what is the difference between the ATMs(per 100,000 adults) of Liberia and ATMs(per 100,000 adults) of Macedonia?
Ensure brevity in your answer.  -52.72. What is the ratio of the ATMs(per 100,000 adults) in High income: nonOECD in 2008 to that in 2009?
Provide a succinct answer. 0.95. What is the ratio of the ATMs(per 100,000 adults) of Burundi in 2008 to that in 2009?
Ensure brevity in your answer.  0.24. What is the ratio of the ATMs(per 100,000 adults) of Liberia in 2008 to that in 2009?
Offer a terse response. 0.76. What is the ratio of the ATMs(per 100,000 adults) of Macedonia in 2008 to that in 2009?
Your answer should be very brief. 0.92. What is the ratio of the ATMs(per 100,000 adults) of High income: nonOECD in 2008 to that in 2010?
Keep it short and to the point. 0.97. What is the ratio of the ATMs(per 100,000 adults) in Burundi in 2008 to that in 2010?
Your answer should be very brief. 0.13. What is the ratio of the ATMs(per 100,000 adults) of Liberia in 2008 to that in 2010?
Your answer should be compact. 0.79. What is the ratio of the ATMs(per 100,000 adults) of Macedonia in 2008 to that in 2010?
Offer a terse response. 0.89. What is the ratio of the ATMs(per 100,000 adults) in High income: nonOECD in 2008 to that in 2011?
Provide a short and direct response. 0.96. What is the ratio of the ATMs(per 100,000 adults) in Burundi in 2008 to that in 2011?
Offer a terse response. 0.1. What is the ratio of the ATMs(per 100,000 adults) of Liberia in 2008 to that in 2011?
Provide a succinct answer. 0.81. What is the ratio of the ATMs(per 100,000 adults) of Macedonia in 2008 to that in 2011?
Keep it short and to the point. 0.88. What is the ratio of the ATMs(per 100,000 adults) in High income: nonOECD in 2008 to that in 2012?
Your response must be concise. 0.87. What is the ratio of the ATMs(per 100,000 adults) in Burundi in 2008 to that in 2012?
Make the answer very short. 0.07. What is the ratio of the ATMs(per 100,000 adults) of Liberia in 2008 to that in 2012?
Make the answer very short. 0.86. What is the ratio of the ATMs(per 100,000 adults) of Macedonia in 2008 to that in 2012?
Offer a very short reply. 0.91. What is the ratio of the ATMs(per 100,000 adults) in High income: nonOECD in 2008 to that in 2013?
Make the answer very short. 0.89. What is the ratio of the ATMs(per 100,000 adults) in Burundi in 2008 to that in 2013?
Your response must be concise. 0.04. What is the ratio of the ATMs(per 100,000 adults) of Liberia in 2008 to that in 2013?
Offer a very short reply. 0.71. What is the ratio of the ATMs(per 100,000 adults) in Macedonia in 2008 to that in 2013?
Offer a very short reply. 0.84. What is the ratio of the ATMs(per 100,000 adults) in High income: nonOECD in 2008 to that in 2014?
Give a very brief answer. 0.85. What is the ratio of the ATMs(per 100,000 adults) in Burundi in 2008 to that in 2014?
Provide a short and direct response. 0.04. What is the ratio of the ATMs(per 100,000 adults) of Liberia in 2008 to that in 2014?
Give a very brief answer. 0.65. What is the ratio of the ATMs(per 100,000 adults) of Macedonia in 2008 to that in 2014?
Make the answer very short. 0.81. What is the ratio of the ATMs(per 100,000 adults) of High income: nonOECD in 2009 to that in 2010?
Ensure brevity in your answer.  1.01. What is the ratio of the ATMs(per 100,000 adults) in Burundi in 2009 to that in 2010?
Ensure brevity in your answer.  0.54. What is the ratio of the ATMs(per 100,000 adults) in Macedonia in 2009 to that in 2010?
Your response must be concise. 0.96. What is the ratio of the ATMs(per 100,000 adults) of High income: nonOECD in 2009 to that in 2011?
Your answer should be very brief. 1.01. What is the ratio of the ATMs(per 100,000 adults) of Burundi in 2009 to that in 2011?
Provide a short and direct response. 0.4. What is the ratio of the ATMs(per 100,000 adults) of Liberia in 2009 to that in 2011?
Offer a very short reply. 1.07. What is the ratio of the ATMs(per 100,000 adults) in Macedonia in 2009 to that in 2011?
Your answer should be very brief. 0.96. What is the ratio of the ATMs(per 100,000 adults) of High income: nonOECD in 2009 to that in 2012?
Your answer should be compact. 0.91. What is the ratio of the ATMs(per 100,000 adults) in Burundi in 2009 to that in 2012?
Keep it short and to the point. 0.29. What is the ratio of the ATMs(per 100,000 adults) of Liberia in 2009 to that in 2012?
Provide a succinct answer. 1.14. What is the ratio of the ATMs(per 100,000 adults) in High income: nonOECD in 2009 to that in 2013?
Your answer should be very brief. 0.93. What is the ratio of the ATMs(per 100,000 adults) of Burundi in 2009 to that in 2013?
Offer a very short reply. 0.18. What is the ratio of the ATMs(per 100,000 adults) in Liberia in 2009 to that in 2013?
Give a very brief answer. 0.94. What is the ratio of the ATMs(per 100,000 adults) in Macedonia in 2009 to that in 2013?
Your answer should be very brief. 0.91. What is the ratio of the ATMs(per 100,000 adults) in High income: nonOECD in 2009 to that in 2014?
Give a very brief answer. 0.9. What is the ratio of the ATMs(per 100,000 adults) in Burundi in 2009 to that in 2014?
Give a very brief answer. 0.19. What is the ratio of the ATMs(per 100,000 adults) of Liberia in 2009 to that in 2014?
Provide a short and direct response. 0.86. What is the ratio of the ATMs(per 100,000 adults) in Macedonia in 2009 to that in 2014?
Provide a succinct answer. 0.88. What is the ratio of the ATMs(per 100,000 adults) of Burundi in 2010 to that in 2011?
Your answer should be compact. 0.74. What is the ratio of the ATMs(per 100,000 adults) in Liberia in 2010 to that in 2011?
Offer a very short reply. 1.03. What is the ratio of the ATMs(per 100,000 adults) in High income: nonOECD in 2010 to that in 2012?
Your answer should be very brief. 0.9. What is the ratio of the ATMs(per 100,000 adults) in Burundi in 2010 to that in 2012?
Give a very brief answer. 0.53. What is the ratio of the ATMs(per 100,000 adults) of Liberia in 2010 to that in 2012?
Offer a very short reply. 1.1. What is the ratio of the ATMs(per 100,000 adults) in Macedonia in 2010 to that in 2012?
Give a very brief answer. 1.03. What is the ratio of the ATMs(per 100,000 adults) of High income: nonOECD in 2010 to that in 2013?
Give a very brief answer. 0.92. What is the ratio of the ATMs(per 100,000 adults) of Burundi in 2010 to that in 2013?
Ensure brevity in your answer.  0.34. What is the ratio of the ATMs(per 100,000 adults) of Liberia in 2010 to that in 2013?
Make the answer very short. 0.9. What is the ratio of the ATMs(per 100,000 adults) of Macedonia in 2010 to that in 2013?
Your answer should be very brief. 0.94. What is the ratio of the ATMs(per 100,000 adults) in High income: nonOECD in 2010 to that in 2014?
Keep it short and to the point. 0.88. What is the ratio of the ATMs(per 100,000 adults) of Burundi in 2010 to that in 2014?
Ensure brevity in your answer.  0.35. What is the ratio of the ATMs(per 100,000 adults) of Liberia in 2010 to that in 2014?
Provide a succinct answer. 0.83. What is the ratio of the ATMs(per 100,000 adults) in Macedonia in 2010 to that in 2014?
Provide a short and direct response. 0.92. What is the ratio of the ATMs(per 100,000 adults) in High income: nonOECD in 2011 to that in 2012?
Give a very brief answer. 0.91. What is the ratio of the ATMs(per 100,000 adults) of Burundi in 2011 to that in 2012?
Offer a terse response. 0.72. What is the ratio of the ATMs(per 100,000 adults) of Liberia in 2011 to that in 2012?
Give a very brief answer. 1.06. What is the ratio of the ATMs(per 100,000 adults) in Macedonia in 2011 to that in 2012?
Ensure brevity in your answer.  1.03. What is the ratio of the ATMs(per 100,000 adults) of High income: nonOECD in 2011 to that in 2013?
Keep it short and to the point. 0.93. What is the ratio of the ATMs(per 100,000 adults) of Burundi in 2011 to that in 2013?
Your response must be concise. 0.46. What is the ratio of the ATMs(per 100,000 adults) in Liberia in 2011 to that in 2013?
Offer a terse response. 0.87. What is the ratio of the ATMs(per 100,000 adults) of Macedonia in 2011 to that in 2013?
Offer a terse response. 0.95. What is the ratio of the ATMs(per 100,000 adults) in High income: nonOECD in 2011 to that in 2014?
Your response must be concise. 0.89. What is the ratio of the ATMs(per 100,000 adults) of Burundi in 2011 to that in 2014?
Offer a terse response. 0.47. What is the ratio of the ATMs(per 100,000 adults) in Liberia in 2011 to that in 2014?
Your answer should be very brief. 0.8. What is the ratio of the ATMs(per 100,000 adults) of Macedonia in 2011 to that in 2014?
Provide a short and direct response. 0.92. What is the ratio of the ATMs(per 100,000 adults) in High income: nonOECD in 2012 to that in 2013?
Provide a short and direct response. 1.02. What is the ratio of the ATMs(per 100,000 adults) in Burundi in 2012 to that in 2013?
Make the answer very short. 0.63. What is the ratio of the ATMs(per 100,000 adults) in Liberia in 2012 to that in 2013?
Provide a short and direct response. 0.82. What is the ratio of the ATMs(per 100,000 adults) of Macedonia in 2012 to that in 2013?
Your answer should be compact. 0.92. What is the ratio of the ATMs(per 100,000 adults) in High income: nonOECD in 2012 to that in 2014?
Make the answer very short. 0.98. What is the ratio of the ATMs(per 100,000 adults) of Burundi in 2012 to that in 2014?
Keep it short and to the point. 0.65. What is the ratio of the ATMs(per 100,000 adults) in Liberia in 2012 to that in 2014?
Your answer should be compact. 0.75. What is the ratio of the ATMs(per 100,000 adults) in Macedonia in 2012 to that in 2014?
Your answer should be compact. 0.89. What is the ratio of the ATMs(per 100,000 adults) in High income: nonOECD in 2013 to that in 2014?
Your response must be concise. 0.96. What is the ratio of the ATMs(per 100,000 adults) of Burundi in 2013 to that in 2014?
Keep it short and to the point. 1.03. What is the ratio of the ATMs(per 100,000 adults) of Liberia in 2013 to that in 2014?
Keep it short and to the point. 0.91. What is the ratio of the ATMs(per 100,000 adults) in Macedonia in 2013 to that in 2014?
Your answer should be very brief. 0.97. What is the difference between the highest and the second highest ATMs(per 100,000 adults) in High income: nonOECD?
Offer a terse response. 1.14. What is the difference between the highest and the second highest ATMs(per 100,000 adults) in Burundi?
Provide a succinct answer. 0.04. What is the difference between the highest and the second highest ATMs(per 100,000 adults) in Liberia?
Make the answer very short. 0.15. What is the difference between the highest and the second highest ATMs(per 100,000 adults) of Macedonia?
Your response must be concise. 1.52. What is the difference between the highest and the lowest ATMs(per 100,000 adults) of High income: nonOECD?
Your answer should be very brief. 8.73. What is the difference between the highest and the lowest ATMs(per 100,000 adults) of Burundi?
Keep it short and to the point. 1.38. What is the difference between the highest and the lowest ATMs(per 100,000 adults) of Liberia?
Give a very brief answer. 0.63. What is the difference between the highest and the lowest ATMs(per 100,000 adults) in Macedonia?
Offer a terse response. 10.15. 